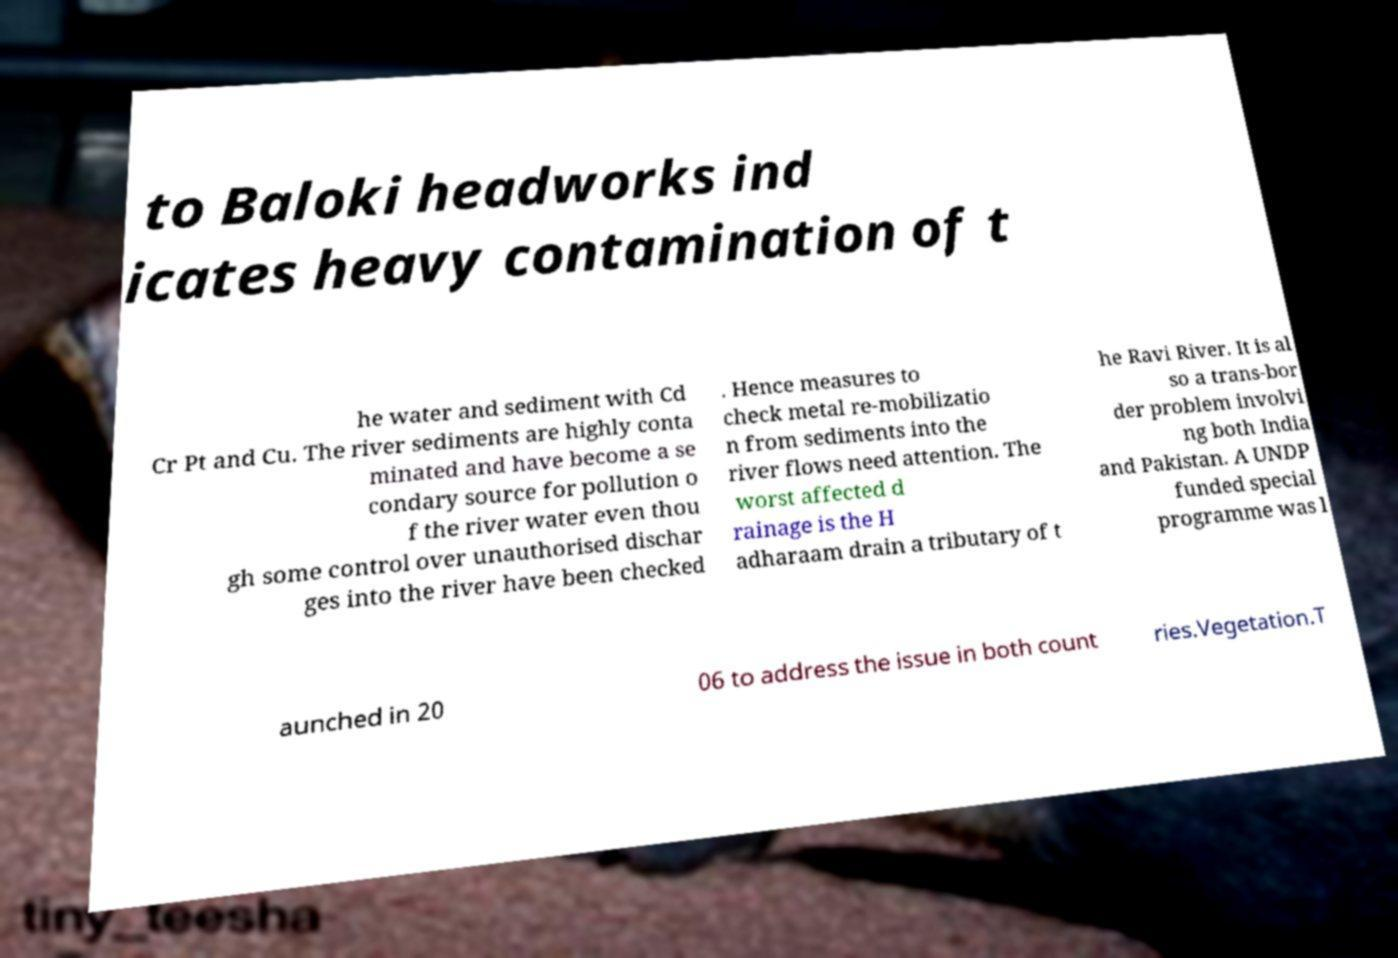What messages or text are displayed in this image? I need them in a readable, typed format. to Baloki headworks ind icates heavy contamination of t he water and sediment with Cd Cr Pt and Cu. The river sediments are highly conta minated and have become a se condary source for pollution o f the river water even thou gh some control over unauthorised dischar ges into the river have been checked . Hence measures to check metal re-mobilizatio n from sediments into the river flows need attention. The worst affected d rainage is the H adharaam drain a tributary of t he Ravi River. It is al so a trans-bor der problem involvi ng both India and Pakistan. A UNDP funded special programme was l aunched in 20 06 to address the issue in both count ries.Vegetation.T 